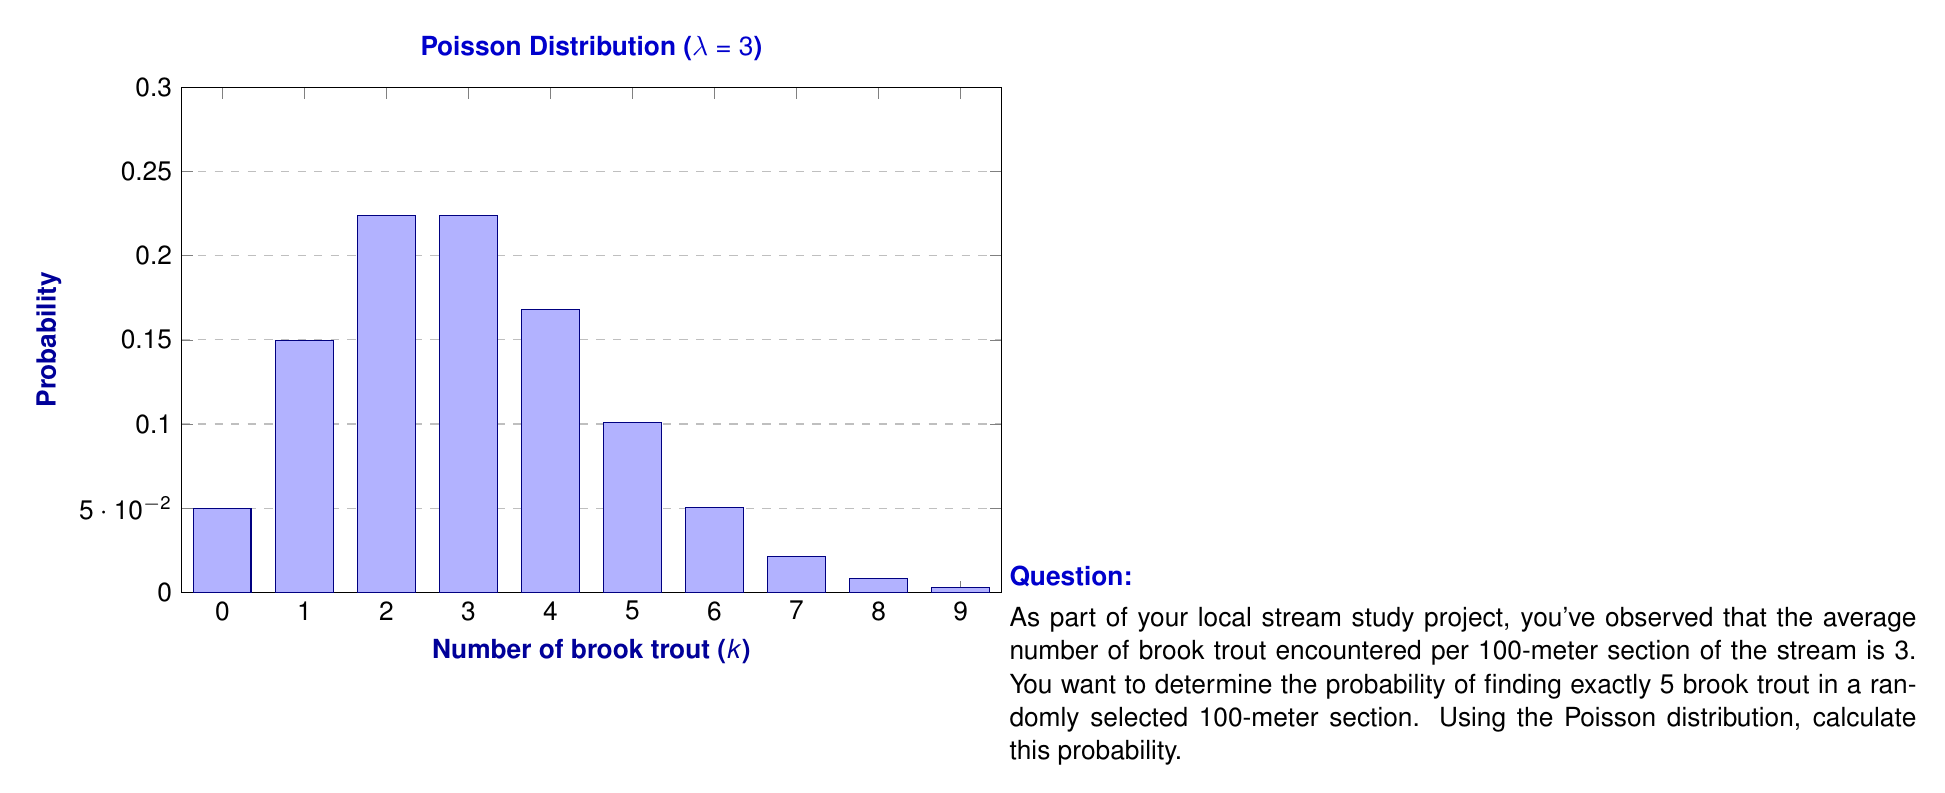What is the answer to this math problem? To solve this problem, we'll use the Poisson distribution formula:

$$P(X = k) = \frac{e^{-\lambda} \lambda^k}{k!}$$

Where:
- $\lambda$ is the average rate of occurrence
- $k$ is the number of occurrences we're interested in
- $e$ is Euler's number (approximately 2.71828)

Given:
- $\lambda = 3$ (average number of brook trout per 100-meter section)
- $k = 5$ (we want exactly 5 brook trout)

Step 1: Substitute the values into the formula.
$$P(X = 5) = \frac{e^{-3} 3^5}{5!}$$

Step 2: Calculate $e^{-3}$.
$e^{-3} \approx 0.0497871$

Step 3: Calculate $3^5$.
$3^5 = 243$

Step 4: Calculate $5!$ (5 factorial).
$5! = 5 \times 4 \times 3 \times 2 \times 1 = 120$

Step 5: Put it all together and calculate the final probability.
$$P(X = 5) = \frac{0.0497871 \times 243}{120} \approx 0.1008$$

Therefore, the probability of encountering exactly 5 brook trout in a randomly selected 100-meter section of the stream is approximately 0.1008 or 10.08%.
Answer: 0.1008 (or 10.08%) 